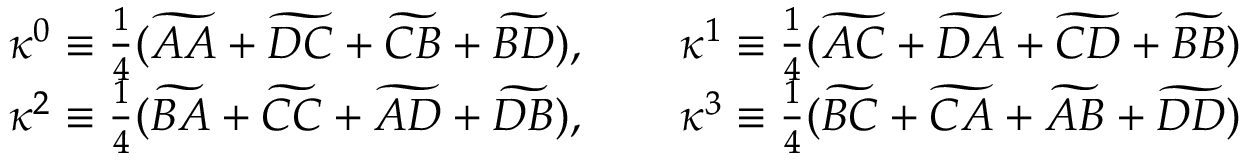<formula> <loc_0><loc_0><loc_500><loc_500>\begin{array} { c c } { \kappa ^ { 0 } \equiv \frac { 1 } { 4 } ( \widetilde { A A } + \widetilde { D C } + \widetilde { C B } + \widetilde { B D } ) , \quad \kappa ^ { 1 } \equiv \frac { 1 } { 4 } ( \widetilde { A C } + \widetilde { D A } + \widetilde { C D } + \widetilde { B B } ) } \\ { \kappa ^ { 2 } \equiv \frac { 1 } { 4 } ( \widetilde { B A } + \widetilde { C C } + \widetilde { A D } + \widetilde { D B } ) , \quad \kappa ^ { 3 } \equiv \frac { 1 } { 4 } ( \widetilde { B C } + \widetilde { C A } + \widetilde { A B } + \widetilde { D D } ) } \end{array}</formula> 